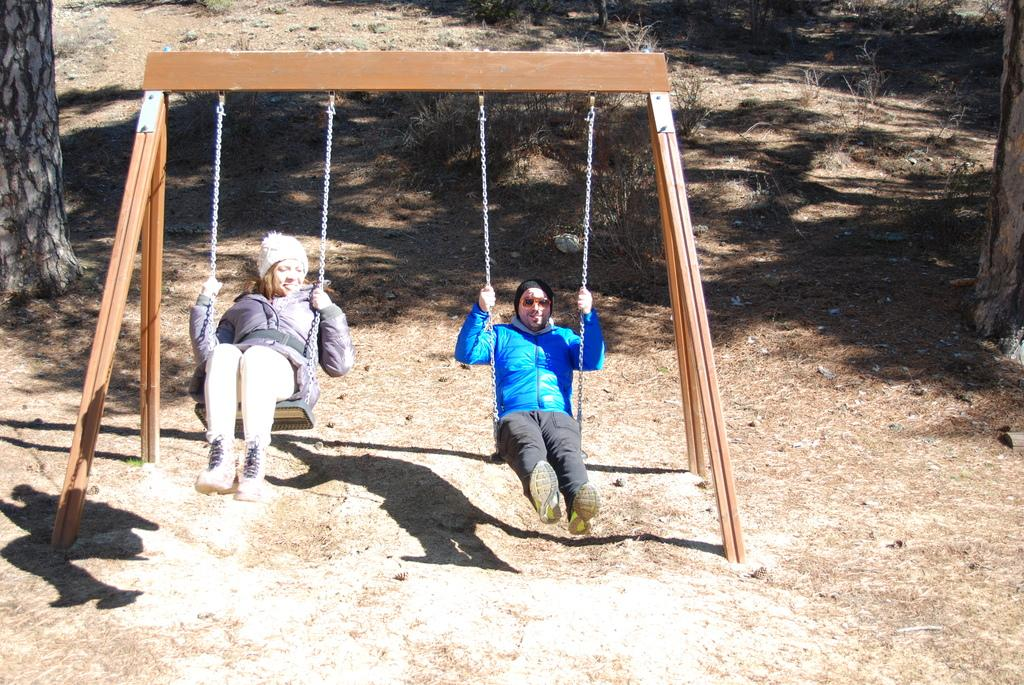Who is present in the image? There is a man and a woman in the image. What are the man and woman doing in the image? Both the man and woman are swinging on swings. What can be seen supporting the swings in the image? There is a tree trunk visible in the image. Can you describe any other features in the image? There is a shadow of a person and dried plants present in the image. What type of iron is being used to balance the swings in the image? There is no iron present in the image, and the swings are not being balanced by any iron objects. Is there a scarecrow visible in the image? No, there is no scarecrow present in the image. 